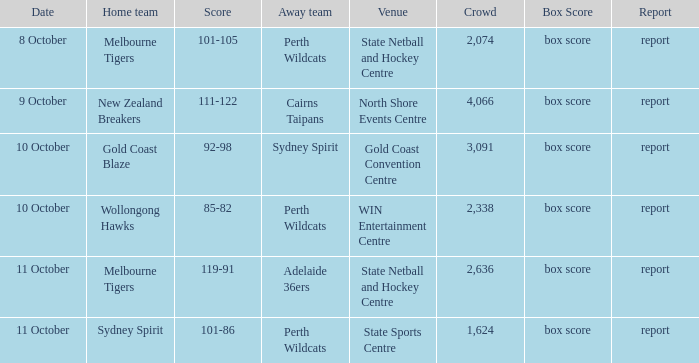I'm looking to parse the entire table for insights. Could you assist me with that? {'header': ['Date', 'Home team', 'Score', 'Away team', 'Venue', 'Crowd', 'Box Score', 'Report'], 'rows': [['8 October', 'Melbourne Tigers', '101-105', 'Perth Wildcats', 'State Netball and Hockey Centre', '2,074', 'box score', 'report'], ['9 October', 'New Zealand Breakers', '111-122', 'Cairns Taipans', 'North Shore Events Centre', '4,066', 'box score', 'report'], ['10 October', 'Gold Coast Blaze', '92-98', 'Sydney Spirit', 'Gold Coast Convention Centre', '3,091', 'box score', 'report'], ['10 October', 'Wollongong Hawks', '85-82', 'Perth Wildcats', 'WIN Entertainment Centre', '2,338', 'box score', 'report'], ['11 October', 'Melbourne Tigers', '119-91', 'Adelaide 36ers', 'State Netball and Hockey Centre', '2,636', 'box score', 'report'], ['11 October', 'Sydney Spirit', '101-86', 'Perth Wildcats', 'State Sports Centre', '1,624', 'box score', 'report']]} What was the audience size for the game that ended with a score of 101-105? 2074.0. 